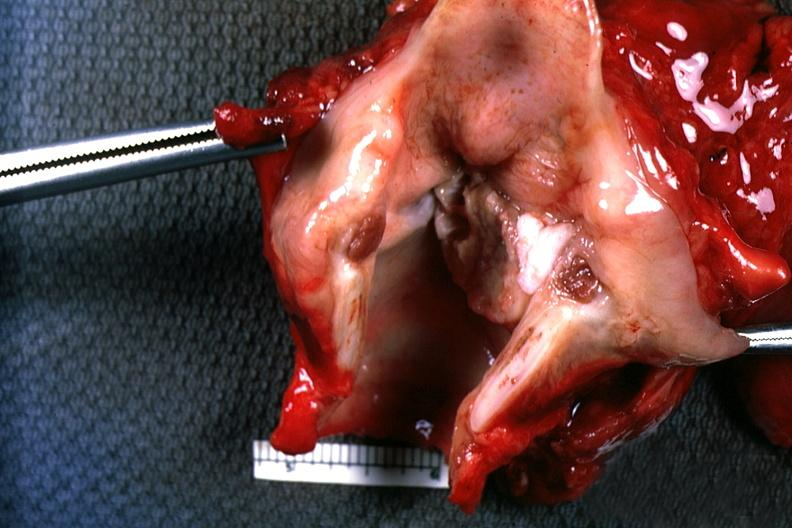does this image show excellent depiction natural color large ulcerative carcinoma on left cord?
Answer the question using a single word or phrase. Yes 